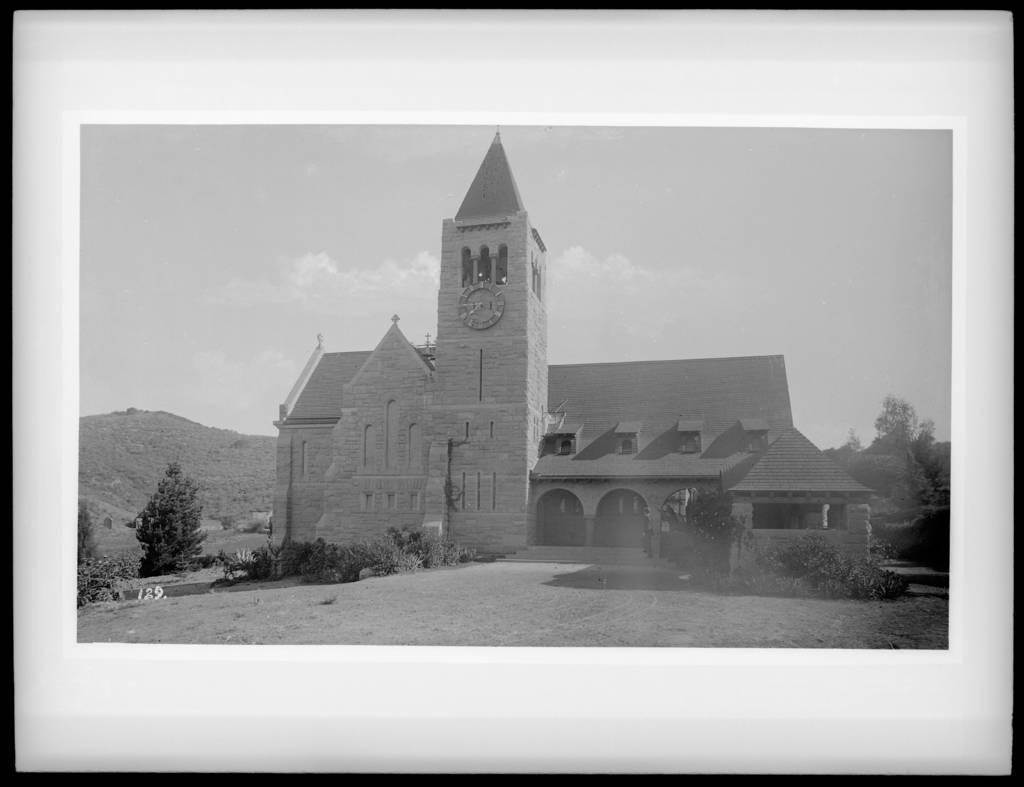What type of structure is in the image? There is a building in the image. What feature is present on the building? A clock is present on the building. What is located in front of the building? There is a group of plants in front of the building. What can be seen in the background of the image? There is a group of trees and a mountain visible in the background, as well as the sky. What type of rice is being cooked in the image? There is no rice present in the image; it features a building with a clock and surrounding vegetation and landscape. 